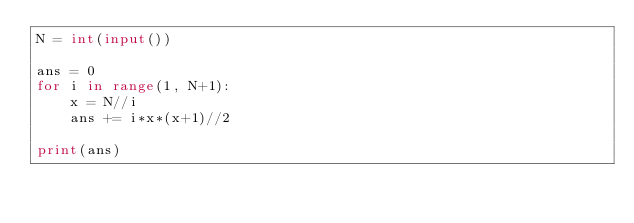<code> <loc_0><loc_0><loc_500><loc_500><_Python_>N = int(input())

ans = 0
for i in range(1, N+1):
    x = N//i
    ans += i*x*(x+1)//2

print(ans) </code> 